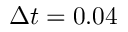<formula> <loc_0><loc_0><loc_500><loc_500>\Delta t = 0 . 0 4</formula> 